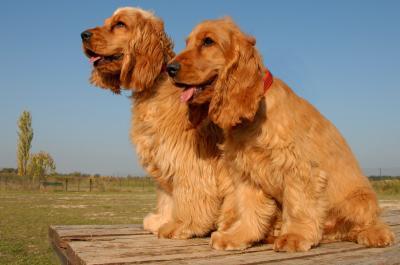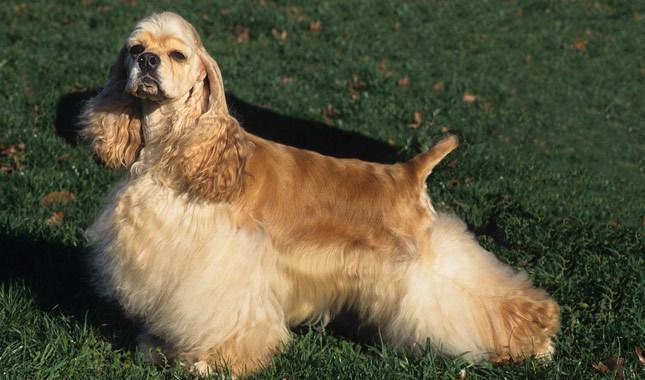The first image is the image on the left, the second image is the image on the right. Assess this claim about the two images: "One dog is on the grass, surrounded by grass.". Correct or not? Answer yes or no. Yes. 